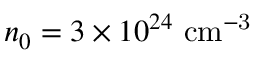Convert formula to latex. <formula><loc_0><loc_0><loc_500><loc_500>n _ { 0 } = 3 \times 1 0 ^ { 2 4 } \ c m ^ { - 3 }</formula> 